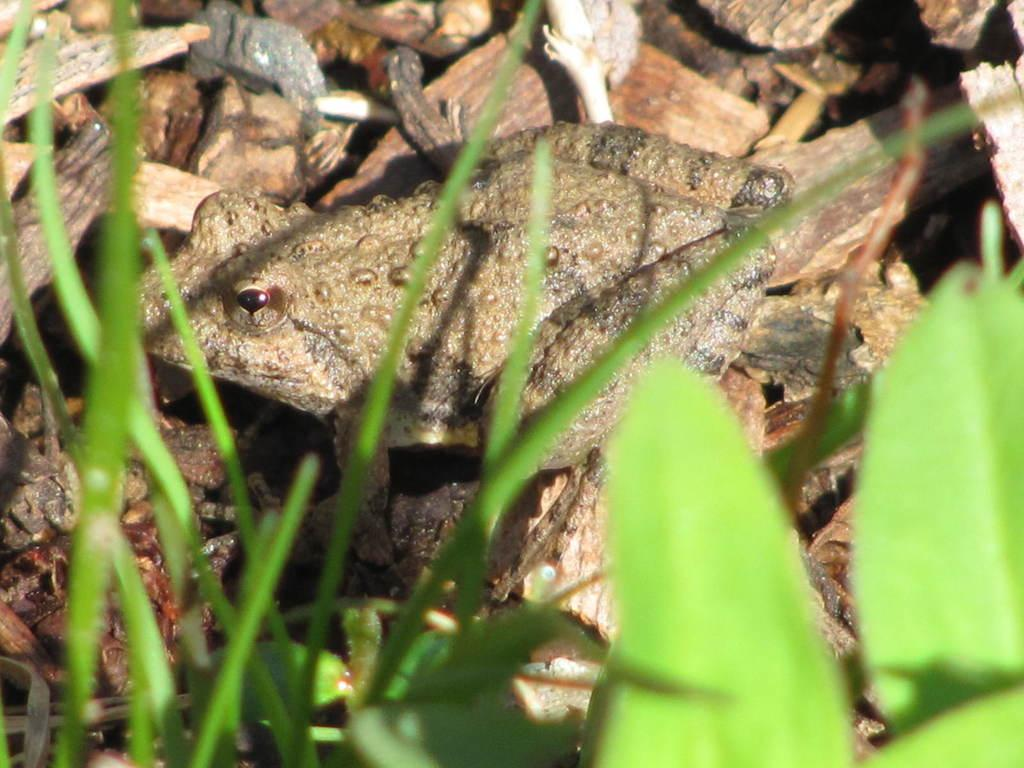What type of animal is present in the image? There is a frog in the image. What other objects or elements can be seen in the image? There are leaves in the image. What type of legal advice can be provided by the frog in the image? There is no indication in the image that the frog is a lawyer or capable of providing legal advice. 